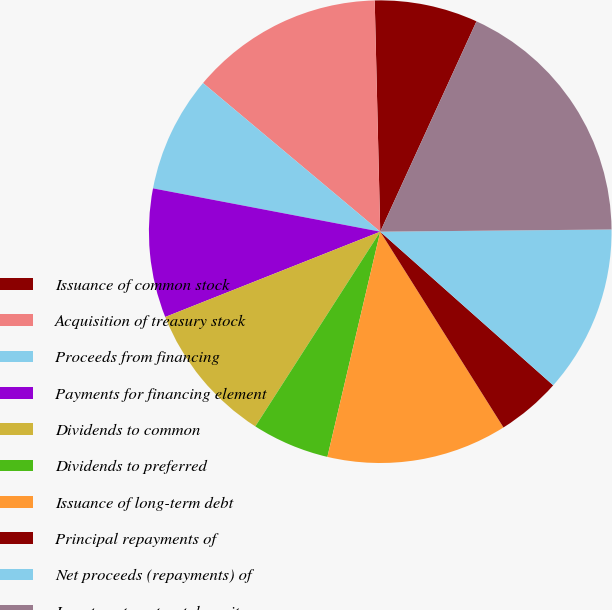<chart> <loc_0><loc_0><loc_500><loc_500><pie_chart><fcel>Issuance of common stock<fcel>Acquisition of treasury stock<fcel>Proceeds from financing<fcel>Payments for financing element<fcel>Dividends to common<fcel>Dividends to preferred<fcel>Issuance of long-term debt<fcel>Principal repayments of<fcel>Net proceeds (repayments) of<fcel>Investment contract deposits<nl><fcel>7.21%<fcel>13.51%<fcel>8.11%<fcel>9.01%<fcel>9.91%<fcel>5.41%<fcel>12.61%<fcel>4.5%<fcel>11.71%<fcel>18.02%<nl></chart> 